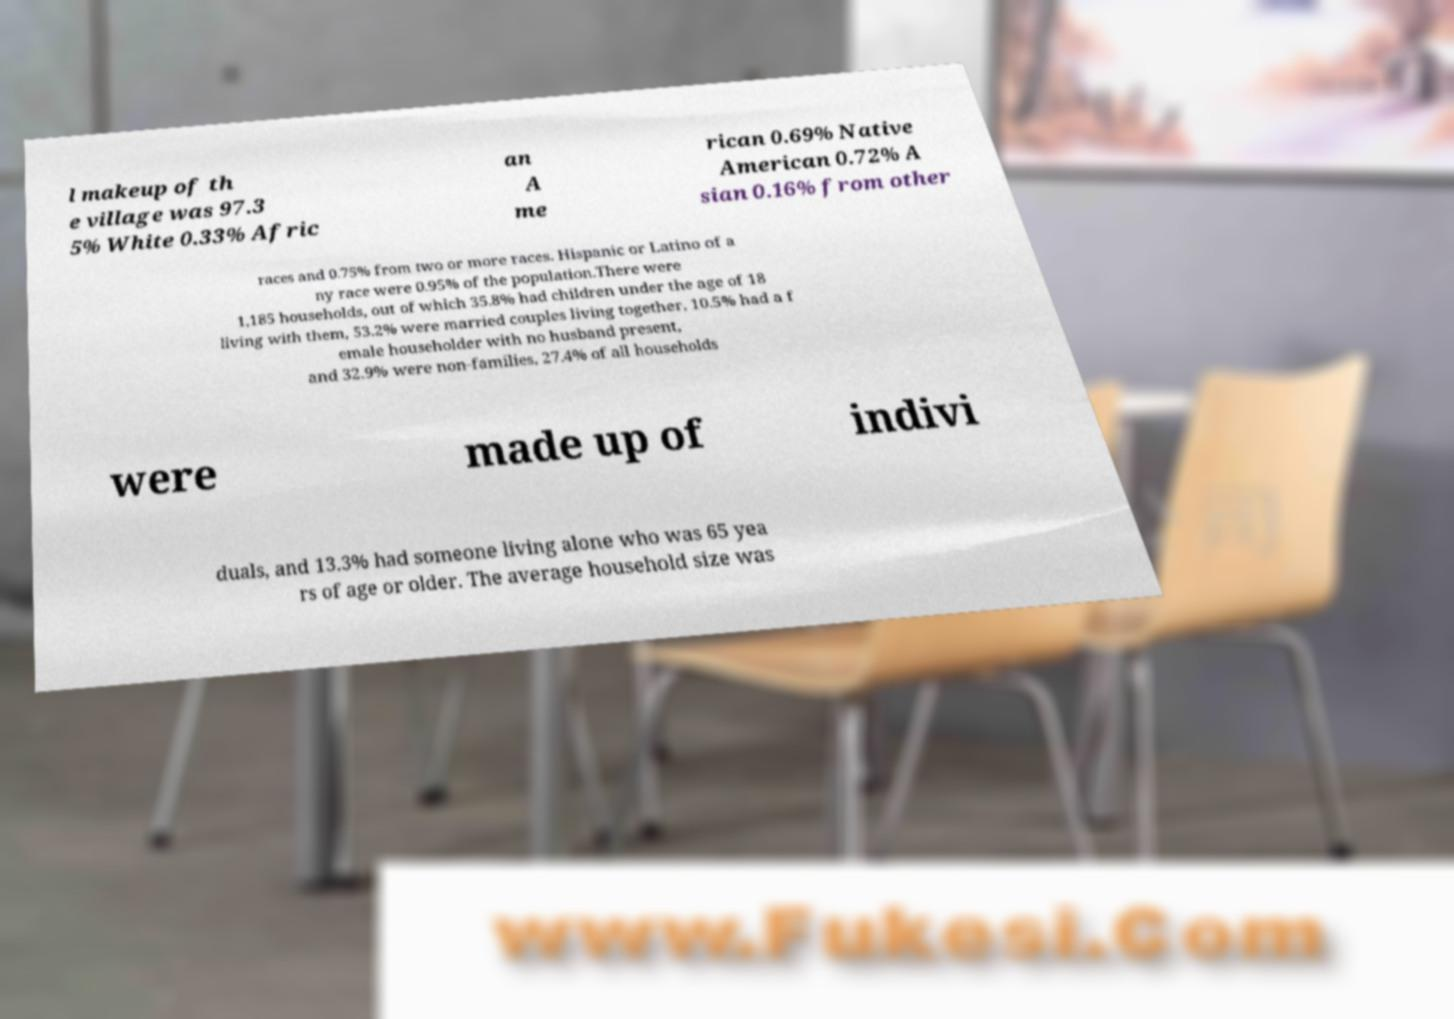Could you assist in decoding the text presented in this image and type it out clearly? l makeup of th e village was 97.3 5% White 0.33% Afric an A me rican 0.69% Native American 0.72% A sian 0.16% from other races and 0.75% from two or more races. Hispanic or Latino of a ny race were 0.95% of the population.There were 1,185 households, out of which 35.8% had children under the age of 18 living with them, 53.2% were married couples living together, 10.5% had a f emale householder with no husband present, and 32.9% were non-families. 27.4% of all households were made up of indivi duals, and 13.3% had someone living alone who was 65 yea rs of age or older. The average household size was 